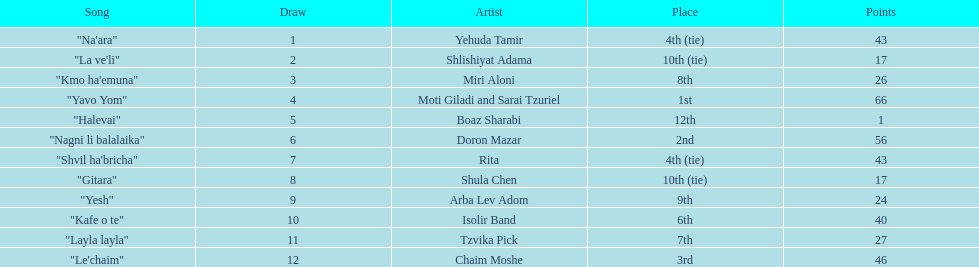What is the total amount of ties in this competition? 2. 